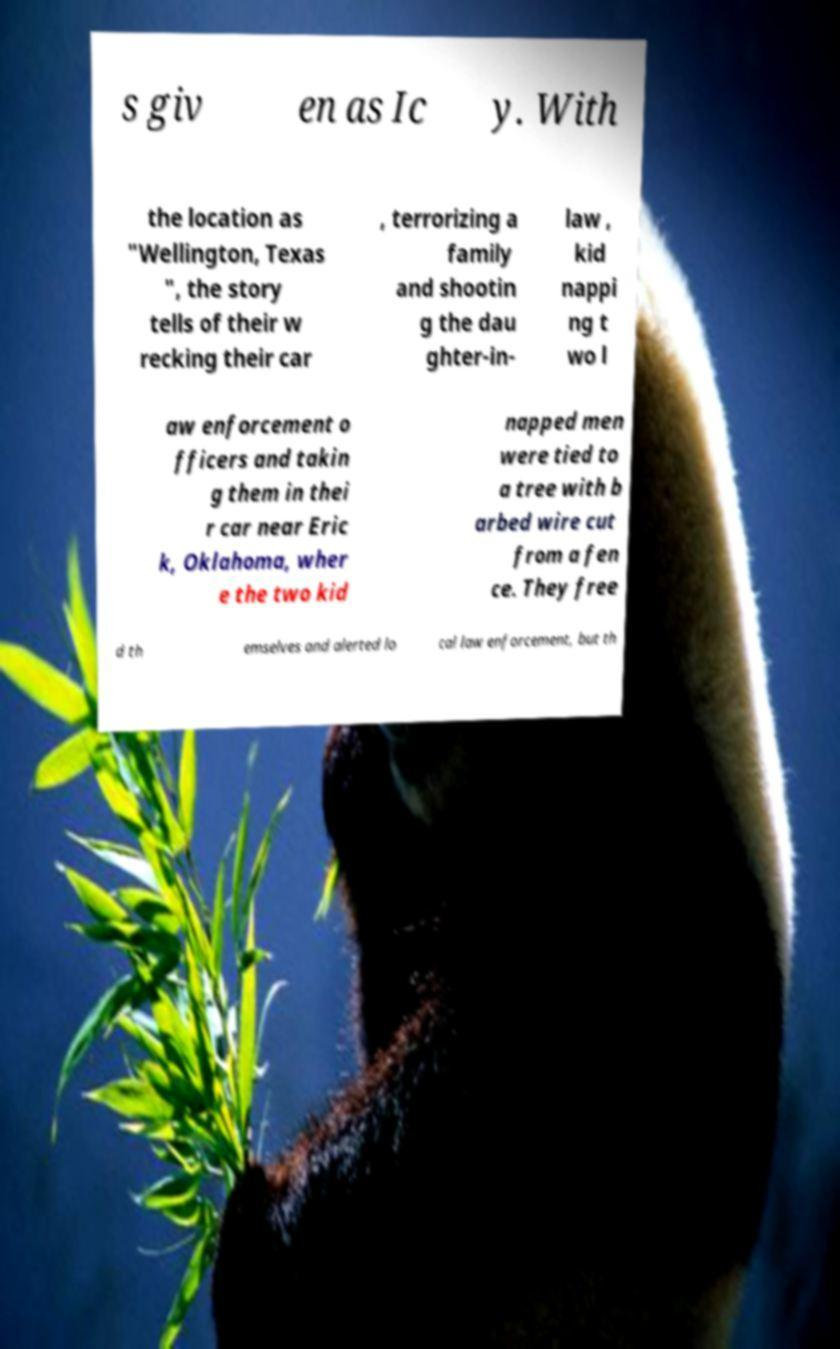Could you extract and type out the text from this image? s giv en as Ic y. With the location as "Wellington, Texas ", the story tells of their w recking their car , terrorizing a family and shootin g the dau ghter-in- law , kid nappi ng t wo l aw enforcement o fficers and takin g them in thei r car near Eric k, Oklahoma, wher e the two kid napped men were tied to a tree with b arbed wire cut from a fen ce. They free d th emselves and alerted lo cal law enforcement, but th 